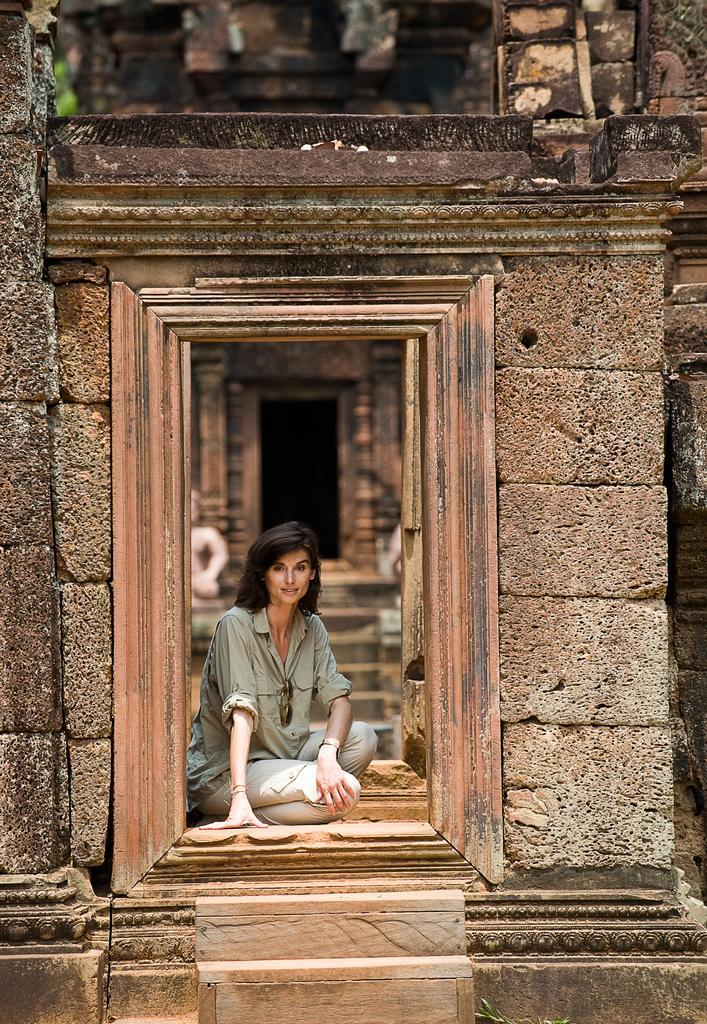In one or two sentences, can you explain what this image depicts? In this image woman is sitting in front of the door. At the back side there is a wall and at the front there are two stairs. 